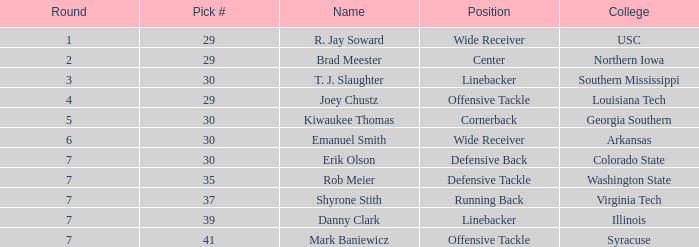What is the average Round for wide receiver r. jay soward and Overall smaller than 29? None. 